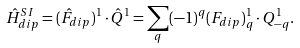Convert formula to latex. <formula><loc_0><loc_0><loc_500><loc_500>\hat { H } ^ { S I } _ { d i p } = ( \hat { F } _ { d i p } ) ^ { 1 } \cdot \hat { Q } ^ { 1 } = \sum _ { q } ( - 1 ) ^ { q } ( F _ { d i p } ) _ { q } ^ { 1 } \cdot Q ^ { 1 } _ { - q } .</formula> 